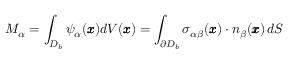Convert formula to latex. <formula><loc_0><loc_0><loc_500><loc_500>M _ { \alpha } = \int _ { { D _ { b } } } \psi _ { \alpha } ( { \pm b x } ) d V ( { \pm b x } ) = \int _ { \partial D _ { b } } { \sigma } _ { \alpha \beta } ( { \pm b x } ) \cdot { n } _ { \beta } ( { \pm b x } ) \, d S</formula> 